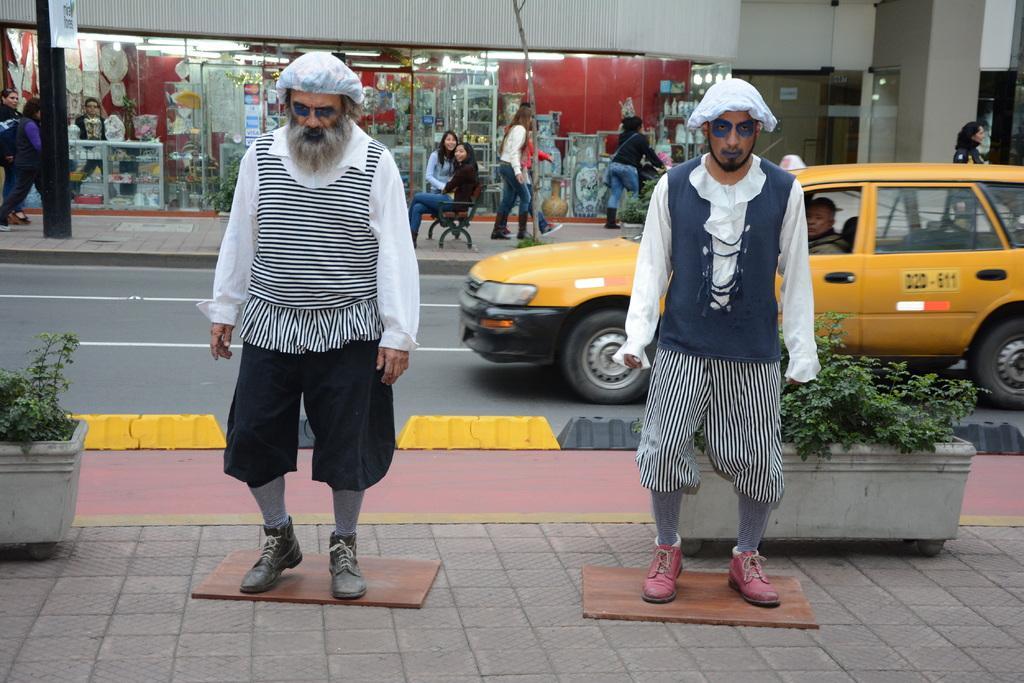Can you describe this image briefly? There are men standing on the footpath. They both are wearing caps on their heads. To the left side there is a pot with the plant in it. On the road there is a yellow color car. In the back side there is a footpath. On the footpath path there a bench with two ladies sitting on it. And some people are standing. In the background there are some stores. 